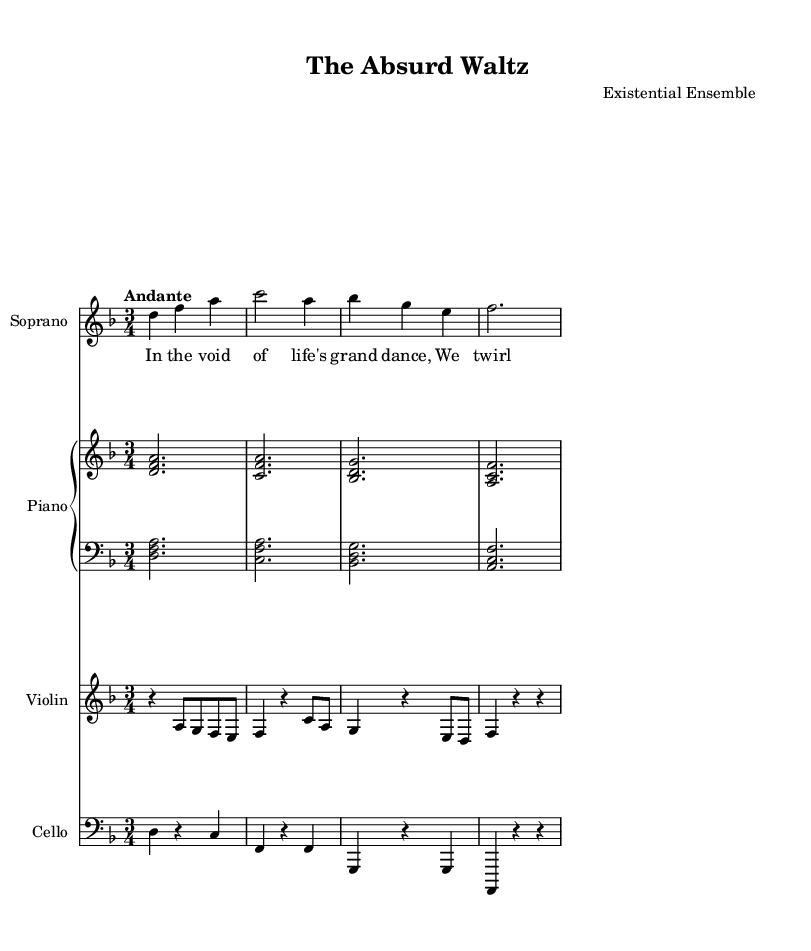What is the key signature of this music? The key signature is indicated at the beginning of the music staff and is D minor, which contains one flat (B flat).
Answer: D minor What is the time signature of this piece? The time signature is found at the beginning, showing how many beats are in each measure. In this case, it is 3/4, meaning there are three beats in each measure, with a quarter note receiving one beat.
Answer: 3/4 What is the tempo marking for this piece? The tempo marking is stated above the staff, where it indicates the speed of the music. Here, it is marked "Andante," which suggests a moderately slow tempo.
Answer: Andante How many instruments are included in this score? By counting the distinct staff members labeled for each instrument, we see that there are four instruments: Soprano, Piano, Violin, and Cello.
Answer: Four Which dynamics are indicated for the Soprano part? The dynamics can be identified by looking for symbols placed above or below the staff lines. The Soprano part is marked with "Up" indicating that the dynamic should be performed with an emphasis.
Answer: Up What kind of operatic theme does this piece explore? By analyzing the lyrics and the title of the opera, "The Absurd Waltz," it can be deduced that the theme explores existentialism and the human condition, reflecting the philosophical context.
Answer: Existentialism What is the lyrical content of the Soprano part? The lyrics can be found directly beneath the notes of the Soprano staff, and they express philosophical thoughts on existence, as shown: "In the void of life's grand dance, We twirl and spin by mere chance."
Answer: Philosophical thoughts on existence 